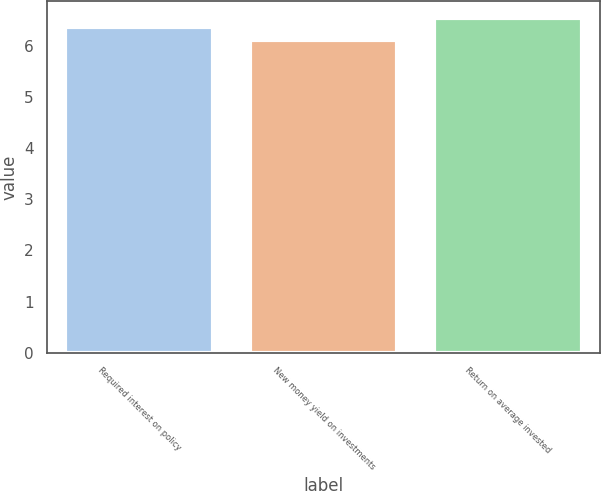Convert chart to OTSL. <chart><loc_0><loc_0><loc_500><loc_500><bar_chart><fcel>Required interest on policy<fcel>New money yield on investments<fcel>Return on average invested<nl><fcel>6.36<fcel>6.11<fcel>6.54<nl></chart> 